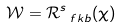<formula> <loc_0><loc_0><loc_500><loc_500>\mathcal { W } = \mathcal { R } ^ { s } _ { \ f k b } ( \chi )</formula> 